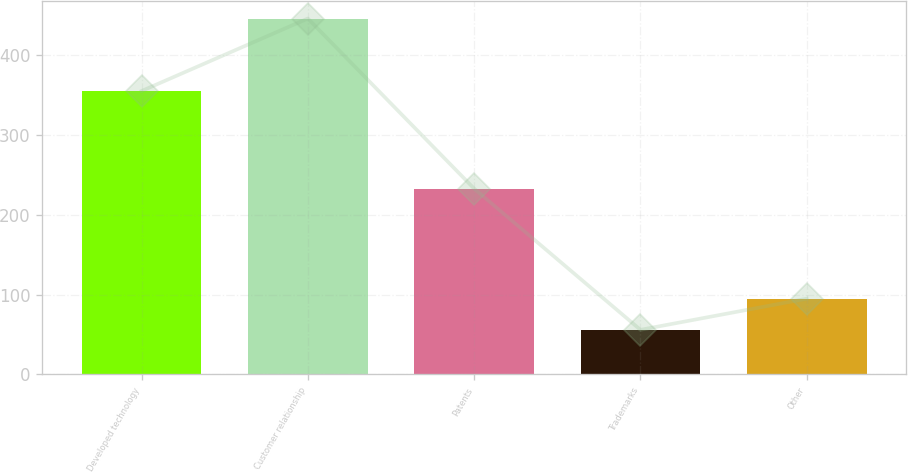<chart> <loc_0><loc_0><loc_500><loc_500><bar_chart><fcel>Developed technology<fcel>Customer relationship<fcel>Patents<fcel>Trademarks<fcel>Other<nl><fcel>355.4<fcel>446.3<fcel>233<fcel>56<fcel>95.03<nl></chart> 